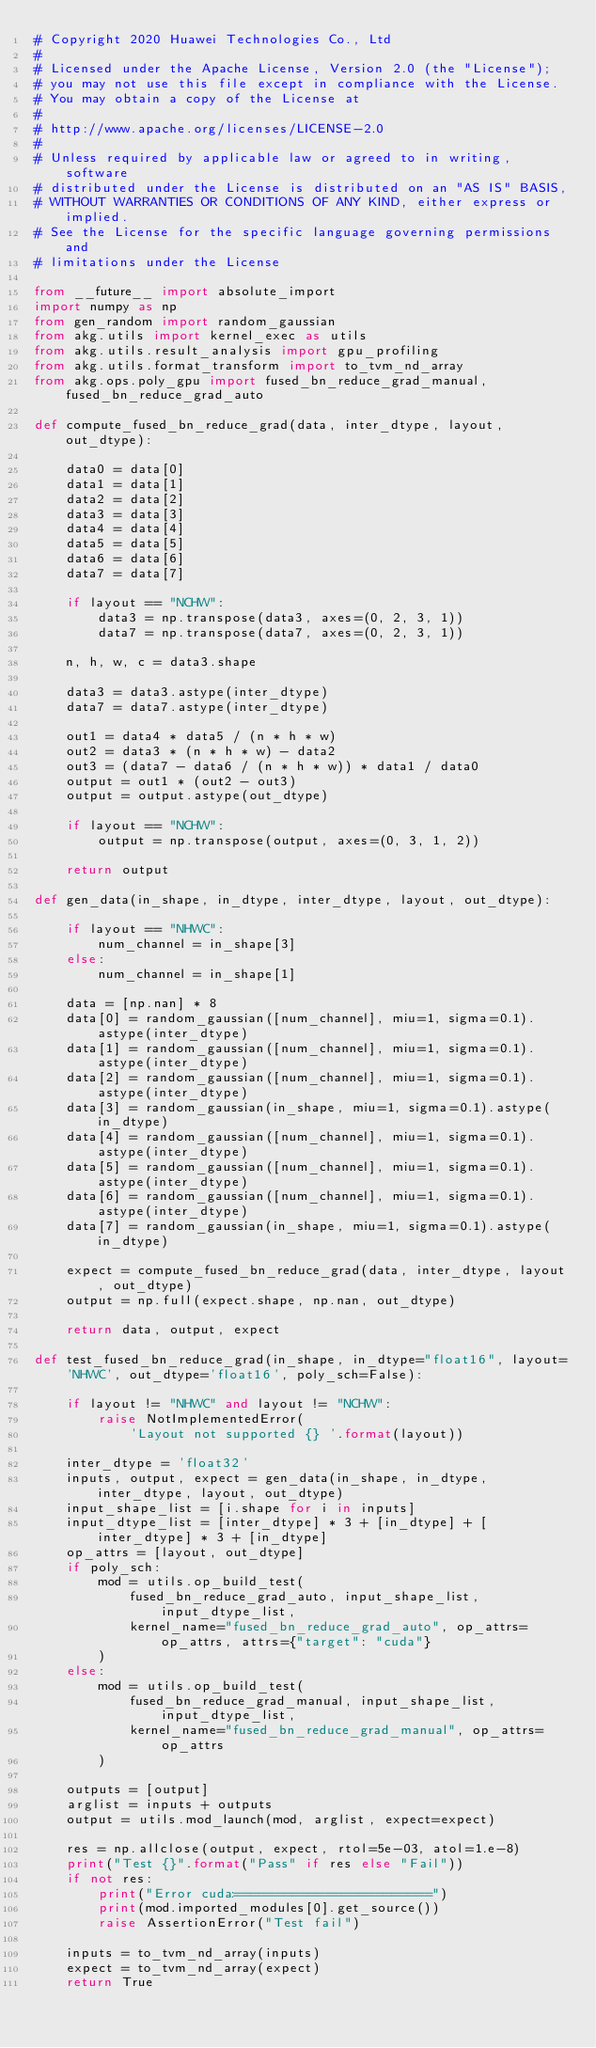<code> <loc_0><loc_0><loc_500><loc_500><_Python_># Copyright 2020 Huawei Technologies Co., Ltd
#
# Licensed under the Apache License, Version 2.0 (the "License");
# you may not use this file except in compliance with the License.
# You may obtain a copy of the License at
#
# http://www.apache.org/licenses/LICENSE-2.0
#
# Unless required by applicable law or agreed to in writing, software
# distributed under the License is distributed on an "AS IS" BASIS,
# WITHOUT WARRANTIES OR CONDITIONS OF ANY KIND, either express or implied.
# See the License for the specific language governing permissions and
# limitations under the License

from __future__ import absolute_import
import numpy as np
from gen_random import random_gaussian
from akg.utils import kernel_exec as utils
from akg.utils.result_analysis import gpu_profiling
from akg.utils.format_transform import to_tvm_nd_array
from akg.ops.poly_gpu import fused_bn_reduce_grad_manual, fused_bn_reduce_grad_auto

def compute_fused_bn_reduce_grad(data, inter_dtype, layout, out_dtype):

    data0 = data[0]
    data1 = data[1]
    data2 = data[2]
    data3 = data[3]
    data4 = data[4]
    data5 = data[5]
    data6 = data[6]
    data7 = data[7]

    if layout == "NCHW":
        data3 = np.transpose(data3, axes=(0, 2, 3, 1))
        data7 = np.transpose(data7, axes=(0, 2, 3, 1))

    n, h, w, c = data3.shape

    data3 = data3.astype(inter_dtype)
    data7 = data7.astype(inter_dtype)

    out1 = data4 * data5 / (n * h * w)
    out2 = data3 * (n * h * w) - data2
    out3 = (data7 - data6 / (n * h * w)) * data1 / data0
    output = out1 * (out2 - out3)
    output = output.astype(out_dtype)

    if layout == "NCHW":
        output = np.transpose(output, axes=(0, 3, 1, 2))

    return output

def gen_data(in_shape, in_dtype, inter_dtype, layout, out_dtype):

    if layout == "NHWC":
        num_channel = in_shape[3]
    else:
        num_channel = in_shape[1]

    data = [np.nan] * 8
    data[0] = random_gaussian([num_channel], miu=1, sigma=0.1).astype(inter_dtype)
    data[1] = random_gaussian([num_channel], miu=1, sigma=0.1).astype(inter_dtype)
    data[2] = random_gaussian([num_channel], miu=1, sigma=0.1).astype(inter_dtype)
    data[3] = random_gaussian(in_shape, miu=1, sigma=0.1).astype(in_dtype)
    data[4] = random_gaussian([num_channel], miu=1, sigma=0.1).astype(inter_dtype)
    data[5] = random_gaussian([num_channel], miu=1, sigma=0.1).astype(inter_dtype)
    data[6] = random_gaussian([num_channel], miu=1, sigma=0.1).astype(inter_dtype)
    data[7] = random_gaussian(in_shape, miu=1, sigma=0.1).astype(in_dtype)

    expect = compute_fused_bn_reduce_grad(data, inter_dtype, layout, out_dtype)
    output = np.full(expect.shape, np.nan, out_dtype)

    return data, output, expect

def test_fused_bn_reduce_grad(in_shape, in_dtype="float16", layout='NHWC', out_dtype='float16', poly_sch=False):

    if layout != "NHWC" and layout != "NCHW":
        raise NotImplementedError(
            'Layout not supported {} '.format(layout))

    inter_dtype = 'float32'
    inputs, output, expect = gen_data(in_shape, in_dtype, inter_dtype, layout, out_dtype)
    input_shape_list = [i.shape for i in inputs]
    input_dtype_list = [inter_dtype] * 3 + [in_dtype] + [inter_dtype] * 3 + [in_dtype]
    op_attrs = [layout, out_dtype]
    if poly_sch:
        mod = utils.op_build_test(
            fused_bn_reduce_grad_auto, input_shape_list, input_dtype_list,
            kernel_name="fused_bn_reduce_grad_auto", op_attrs=op_attrs, attrs={"target": "cuda"}
        )
    else:
        mod = utils.op_build_test(
            fused_bn_reduce_grad_manual, input_shape_list, input_dtype_list,
            kernel_name="fused_bn_reduce_grad_manual", op_attrs=op_attrs
        )

    outputs = [output]
    arglist = inputs + outputs
    output = utils.mod_launch(mod, arglist, expect=expect)

    res = np.allclose(output, expect, rtol=5e-03, atol=1.e-8)
    print("Test {}".format("Pass" if res else "Fail"))
    if not res:
        print("Error cuda:========================")
        print(mod.imported_modules[0].get_source())
        raise AssertionError("Test fail")

    inputs = to_tvm_nd_array(inputs)
    expect = to_tvm_nd_array(expect)
    return True
</code> 